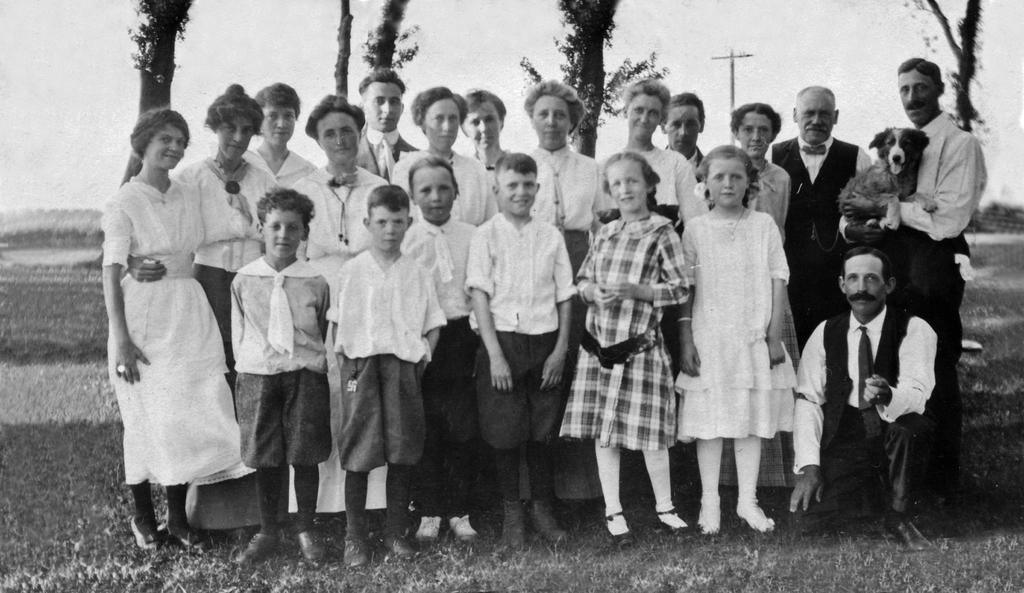Can you describe this image briefly? This is a black and white image, in this image there are a group of people standing and also there are some children. At the bottom there is grass, and in the background there are trees and pole. 